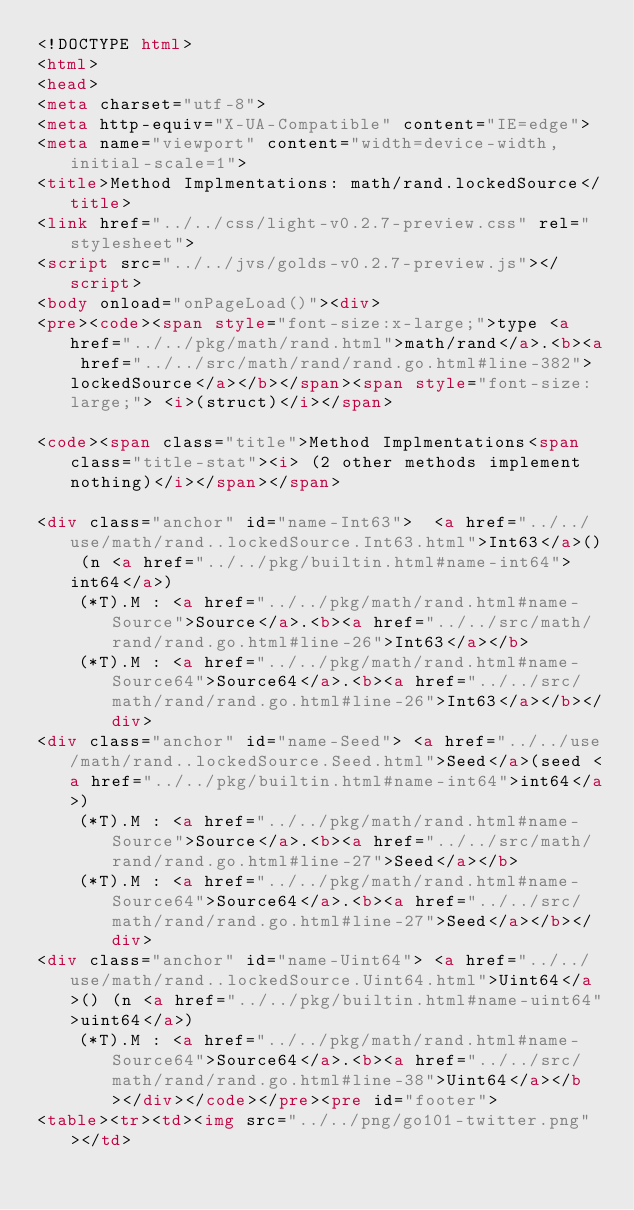Convert code to text. <code><loc_0><loc_0><loc_500><loc_500><_HTML_><!DOCTYPE html>
<html>
<head>
<meta charset="utf-8">
<meta http-equiv="X-UA-Compatible" content="IE=edge">
<meta name="viewport" content="width=device-width, initial-scale=1">
<title>Method Implmentations: math/rand.lockedSource</title>
<link href="../../css/light-v0.2.7-preview.css" rel="stylesheet">
<script src="../../jvs/golds-v0.2.7-preview.js"></script>
<body onload="onPageLoad()"><div>
<pre><code><span style="font-size:x-large;">type <a href="../../pkg/math/rand.html">math/rand</a>.<b><a href="../../src/math/rand/rand.go.html#line-382">lockedSource</a></b></span><span style="font-size:large;"> <i>(struct)</i></span>

<code><span class="title">Method Implmentations<span class="title-stat"><i> (2 other methods implement nothing)</i></span></span>

<div class="anchor" id="name-Int63">	<a href="../../use/math/rand..lockedSource.Int63.html">Int63</a>() (n <a href="../../pkg/builtin.html#name-int64">int64</a>)
		(*T).M : <a href="../../pkg/math/rand.html#name-Source">Source</a>.<b><a href="../../src/math/rand/rand.go.html#line-26">Int63</a></b>
		(*T).M : <a href="../../pkg/math/rand.html#name-Source64">Source64</a>.<b><a href="../../src/math/rand/rand.go.html#line-26">Int63</a></b></div>
<div class="anchor" id="name-Seed">	<a href="../../use/math/rand..lockedSource.Seed.html">Seed</a>(seed <a href="../../pkg/builtin.html#name-int64">int64</a>)
		(*T).M : <a href="../../pkg/math/rand.html#name-Source">Source</a>.<b><a href="../../src/math/rand/rand.go.html#line-27">Seed</a></b>
		(*T).M : <a href="../../pkg/math/rand.html#name-Source64">Source64</a>.<b><a href="../../src/math/rand/rand.go.html#line-27">Seed</a></b></div>
<div class="anchor" id="name-Uint64">	<a href="../../use/math/rand..lockedSource.Uint64.html">Uint64</a>() (n <a href="../../pkg/builtin.html#name-uint64">uint64</a>)
		(*T).M : <a href="../../pkg/math/rand.html#name-Source64">Source64</a>.<b><a href="../../src/math/rand/rand.go.html#line-38">Uint64</a></b></div></code></pre><pre id="footer">
<table><tr><td><img src="../../png/go101-twitter.png"></td></code> 